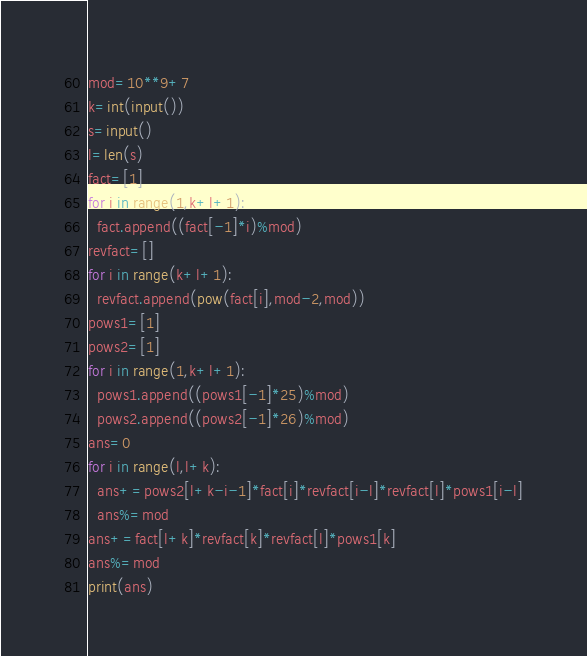<code> <loc_0><loc_0><loc_500><loc_500><_Python_>mod=10**9+7
k=int(input())
s=input()
l=len(s)
fact=[1]
for i in range(1,k+l+1):
  fact.append((fact[-1]*i)%mod)
revfact=[]
for i in range(k+l+1):
  revfact.append(pow(fact[i],mod-2,mod))
pows1=[1]
pows2=[1]
for i in range(1,k+l+1):
  pows1.append((pows1[-1]*25)%mod)
  pows2.append((pows2[-1]*26)%mod)
ans=0
for i in range(l,l+k):
  ans+=pows2[l+k-i-1]*fact[i]*revfact[i-l]*revfact[l]*pows1[i-l]
  ans%=mod
ans+=fact[l+k]*revfact[k]*revfact[l]*pows1[k]
ans%=mod
print(ans)</code> 